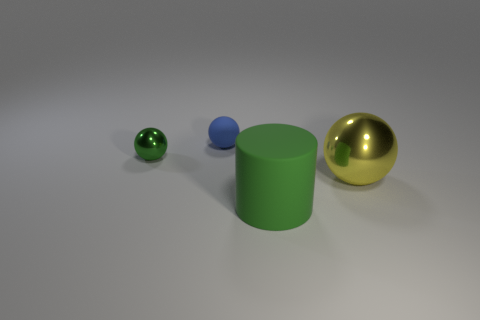Subtract all large yellow balls. How many balls are left? 2 Add 2 big green objects. How many objects exist? 6 Subtract all balls. How many objects are left? 1 Add 1 tiny gray rubber things. How many tiny gray rubber things exist? 1 Subtract 0 blue cylinders. How many objects are left? 4 Subtract all small things. Subtract all large yellow shiny things. How many objects are left? 1 Add 4 big metal balls. How many big metal balls are left? 5 